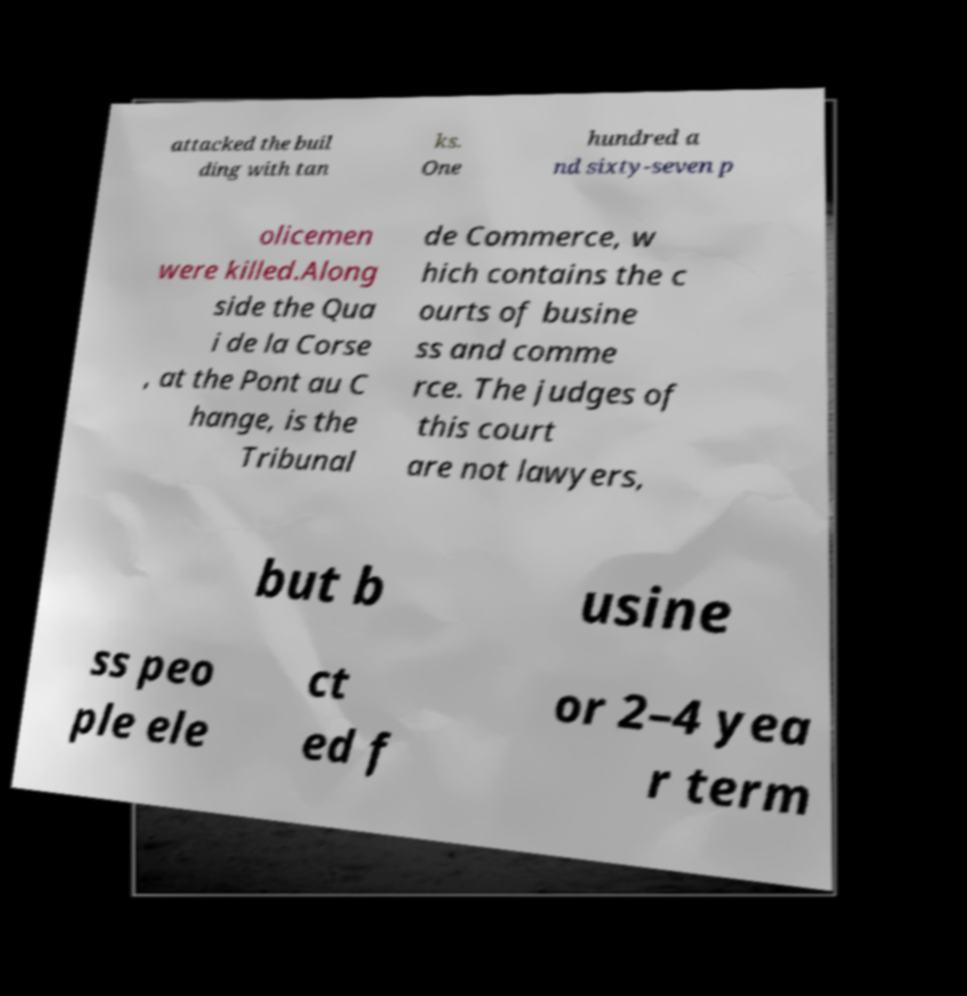Could you extract and type out the text from this image? attacked the buil ding with tan ks. One hundred a nd sixty-seven p olicemen were killed.Along side the Qua i de la Corse , at the Pont au C hange, is the Tribunal de Commerce, w hich contains the c ourts of busine ss and comme rce. The judges of this court are not lawyers, but b usine ss peo ple ele ct ed f or 2–4 yea r term 